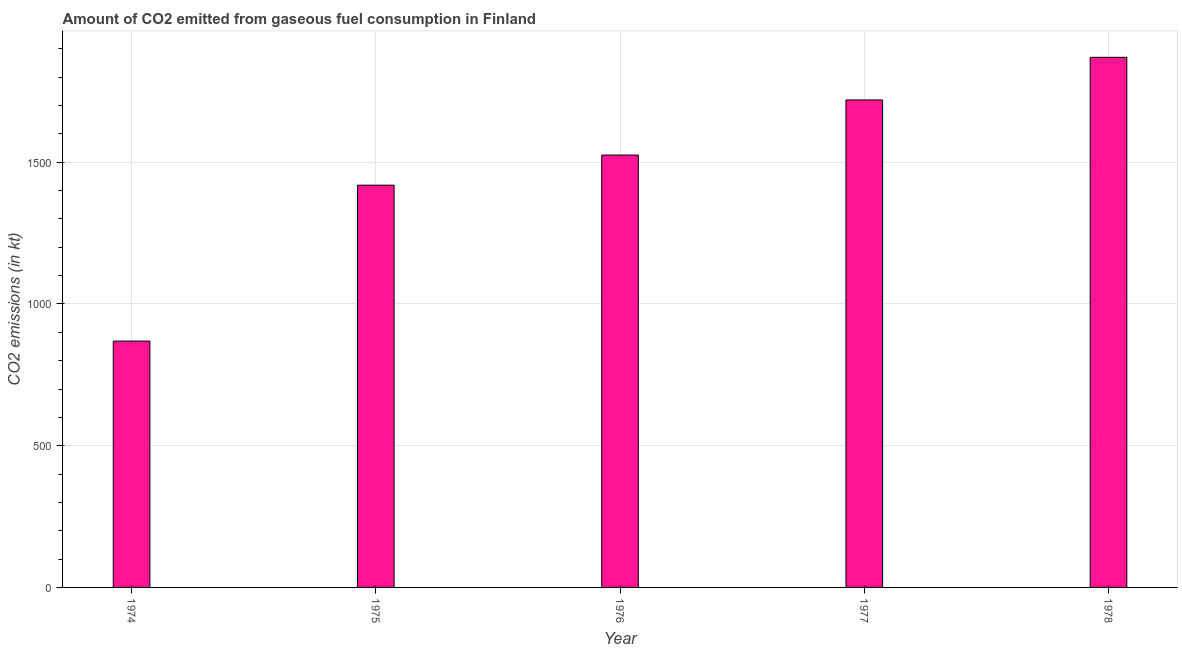What is the title of the graph?
Ensure brevity in your answer.  Amount of CO2 emitted from gaseous fuel consumption in Finland. What is the label or title of the X-axis?
Your answer should be compact. Year. What is the label or title of the Y-axis?
Provide a short and direct response. CO2 emissions (in kt). What is the co2 emissions from gaseous fuel consumption in 1978?
Ensure brevity in your answer.  1870.17. Across all years, what is the maximum co2 emissions from gaseous fuel consumption?
Your answer should be very brief. 1870.17. Across all years, what is the minimum co2 emissions from gaseous fuel consumption?
Provide a short and direct response. 869.08. In which year was the co2 emissions from gaseous fuel consumption maximum?
Ensure brevity in your answer.  1978. In which year was the co2 emissions from gaseous fuel consumption minimum?
Offer a terse response. 1974. What is the sum of the co2 emissions from gaseous fuel consumption?
Your answer should be compact. 7403.67. What is the difference between the co2 emissions from gaseous fuel consumption in 1974 and 1976?
Give a very brief answer. -656.39. What is the average co2 emissions from gaseous fuel consumption per year?
Your answer should be compact. 1480.73. What is the median co2 emissions from gaseous fuel consumption?
Offer a very short reply. 1525.47. In how many years, is the co2 emissions from gaseous fuel consumption greater than 1100 kt?
Provide a succinct answer. 4. Do a majority of the years between 1975 and 1974 (inclusive) have co2 emissions from gaseous fuel consumption greater than 100 kt?
Give a very brief answer. No. What is the ratio of the co2 emissions from gaseous fuel consumption in 1974 to that in 1977?
Ensure brevity in your answer.  0.51. Is the co2 emissions from gaseous fuel consumption in 1975 less than that in 1976?
Offer a terse response. Yes. What is the difference between the highest and the second highest co2 emissions from gaseous fuel consumption?
Ensure brevity in your answer.  150.35. What is the difference between the highest and the lowest co2 emissions from gaseous fuel consumption?
Your answer should be compact. 1001.09. In how many years, is the co2 emissions from gaseous fuel consumption greater than the average co2 emissions from gaseous fuel consumption taken over all years?
Provide a short and direct response. 3. How many bars are there?
Give a very brief answer. 5. Are all the bars in the graph horizontal?
Provide a succinct answer. No. How many years are there in the graph?
Offer a very short reply. 5. Are the values on the major ticks of Y-axis written in scientific E-notation?
Provide a short and direct response. No. What is the CO2 emissions (in kt) of 1974?
Your answer should be compact. 869.08. What is the CO2 emissions (in kt) in 1975?
Offer a terse response. 1419.13. What is the CO2 emissions (in kt) in 1976?
Give a very brief answer. 1525.47. What is the CO2 emissions (in kt) in 1977?
Offer a terse response. 1719.82. What is the CO2 emissions (in kt) in 1978?
Offer a terse response. 1870.17. What is the difference between the CO2 emissions (in kt) in 1974 and 1975?
Your answer should be very brief. -550.05. What is the difference between the CO2 emissions (in kt) in 1974 and 1976?
Your response must be concise. -656.39. What is the difference between the CO2 emissions (in kt) in 1974 and 1977?
Make the answer very short. -850.74. What is the difference between the CO2 emissions (in kt) in 1974 and 1978?
Offer a very short reply. -1001.09. What is the difference between the CO2 emissions (in kt) in 1975 and 1976?
Ensure brevity in your answer.  -106.34. What is the difference between the CO2 emissions (in kt) in 1975 and 1977?
Give a very brief answer. -300.69. What is the difference between the CO2 emissions (in kt) in 1975 and 1978?
Your answer should be compact. -451.04. What is the difference between the CO2 emissions (in kt) in 1976 and 1977?
Give a very brief answer. -194.35. What is the difference between the CO2 emissions (in kt) in 1976 and 1978?
Provide a short and direct response. -344.7. What is the difference between the CO2 emissions (in kt) in 1977 and 1978?
Keep it short and to the point. -150.35. What is the ratio of the CO2 emissions (in kt) in 1974 to that in 1975?
Give a very brief answer. 0.61. What is the ratio of the CO2 emissions (in kt) in 1974 to that in 1976?
Give a very brief answer. 0.57. What is the ratio of the CO2 emissions (in kt) in 1974 to that in 1977?
Your answer should be very brief. 0.51. What is the ratio of the CO2 emissions (in kt) in 1974 to that in 1978?
Ensure brevity in your answer.  0.47. What is the ratio of the CO2 emissions (in kt) in 1975 to that in 1976?
Ensure brevity in your answer.  0.93. What is the ratio of the CO2 emissions (in kt) in 1975 to that in 1977?
Your answer should be compact. 0.82. What is the ratio of the CO2 emissions (in kt) in 1975 to that in 1978?
Your answer should be compact. 0.76. What is the ratio of the CO2 emissions (in kt) in 1976 to that in 1977?
Your response must be concise. 0.89. What is the ratio of the CO2 emissions (in kt) in 1976 to that in 1978?
Your answer should be very brief. 0.82. What is the ratio of the CO2 emissions (in kt) in 1977 to that in 1978?
Your answer should be very brief. 0.92. 